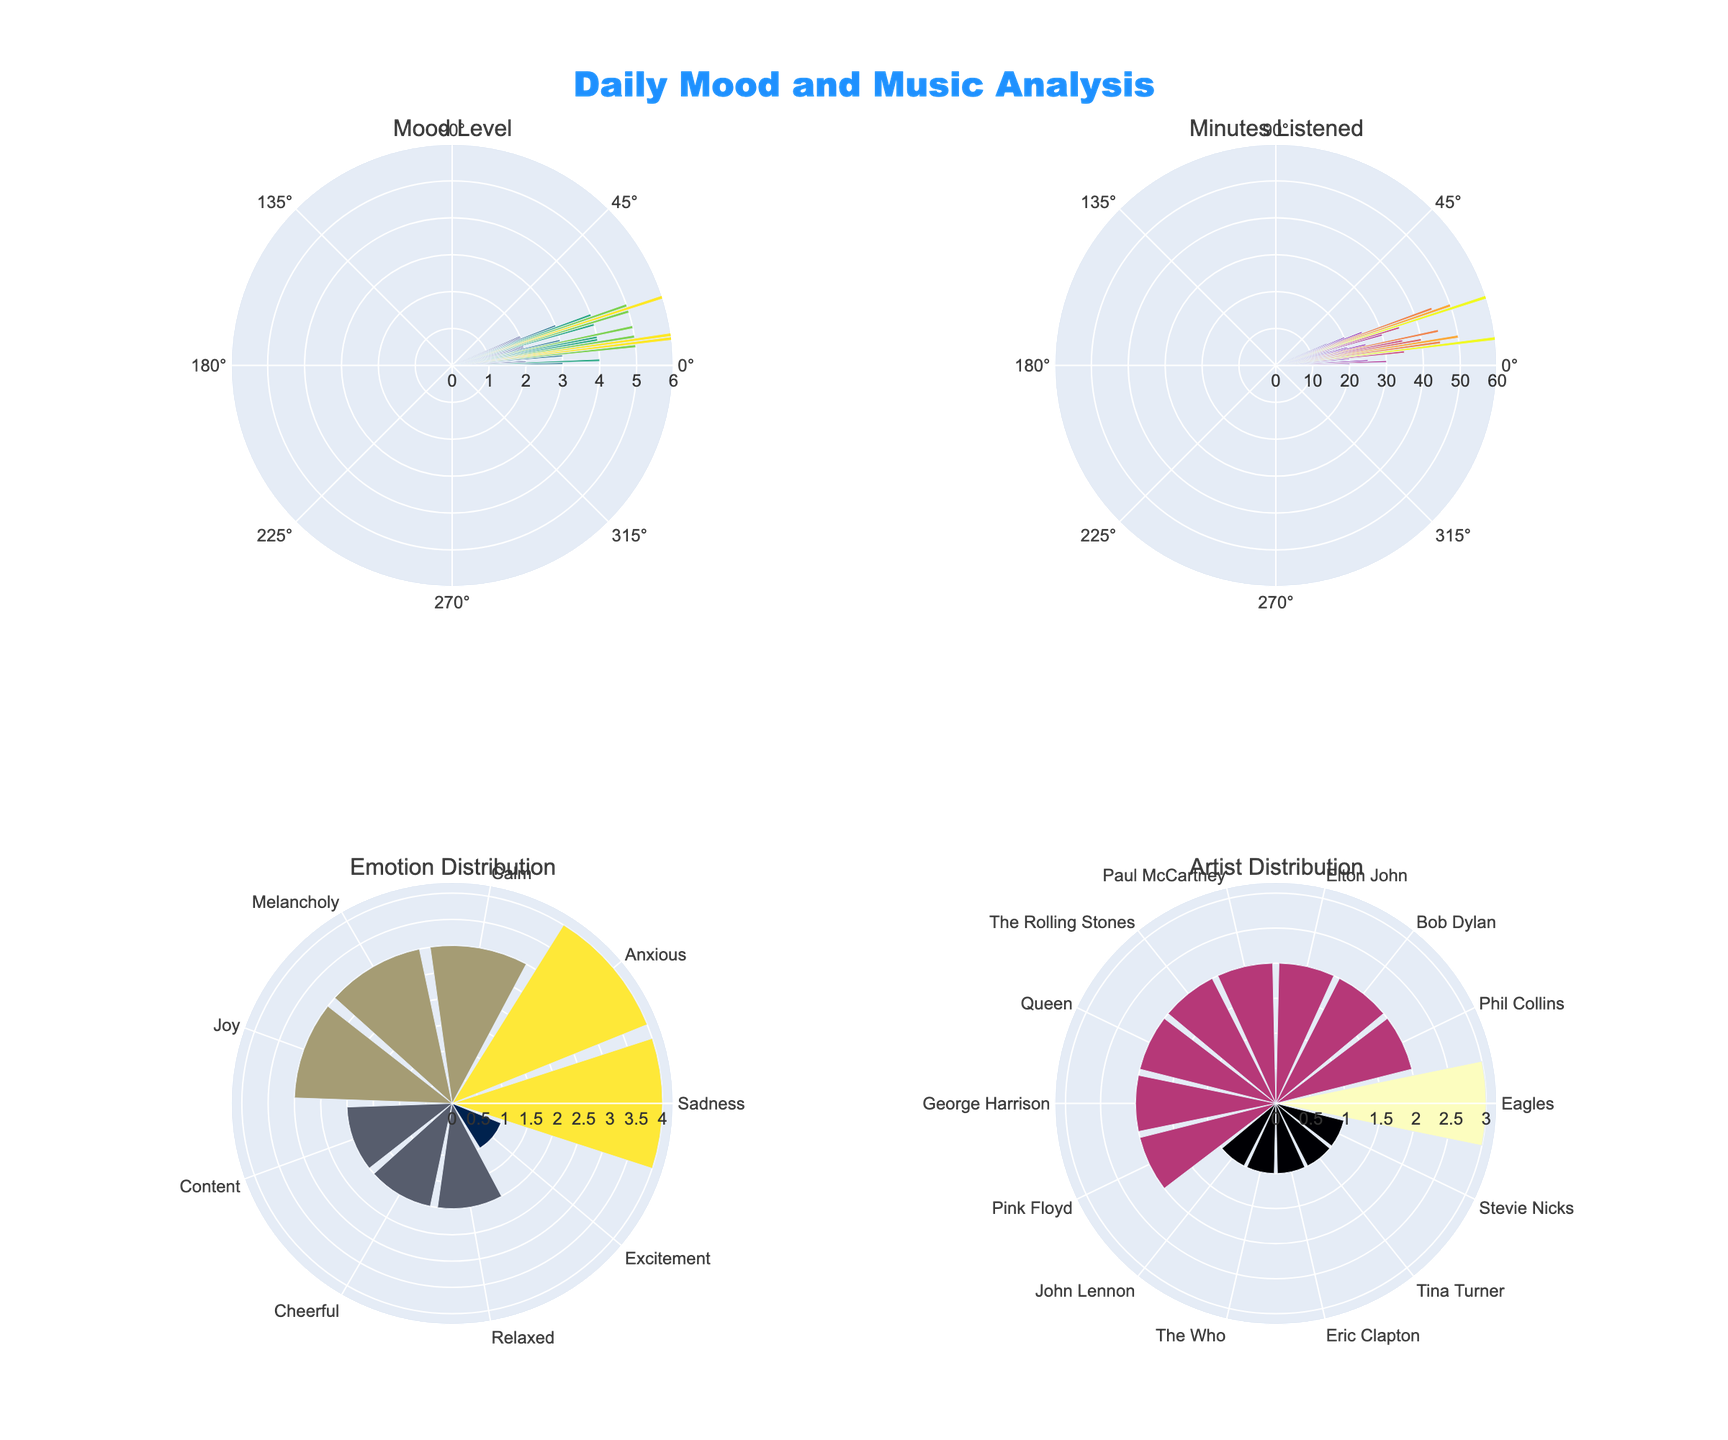which time of day has the highest mood level? By observing the 'Mood Level' subplot in the figure, the time corresponding to the highest radial value represents the highest mood level.
Answer: 07:00 which emotion is observed most frequently throughout the day? By looking at the 'Emotion Distribution' subplot, count the bars and identify the emotion with the highest bar.
Answer: Anxious between 'minutes listened' and 'mood level', which variable has a wider range of values throughout the day? Compare the radial axis range of 'Minutes Listened' and 'Mood Level' subplots; minutes listened ranges up to 60, while mood level ranges up to 6.
Answer: Minutes Listened what time of the day has the highest minutes listened? Look at the 'Minutes Listened' subplot and find the time with the highest radial value.
Answer: 07:00 which artist has the most frequent listening occurrences? Check the 'Artist Distribution' subplot, counting the height of the bars to identify the artist with the largest bar.
Answer: Eagles how many times is 'relaxed' emotions recorded throughout the day? Refer to the 'Emotion Distribution' subplot, looking at the 'Relaxed' bar and checking its value.
Answer: 2 are cheerful moods more frequent in the morning or evening? Look at the 'Mood Level' subplot, identify 'Cheerful' moods, and compare their frequencies between morning and evening hours.
Answer: Evening which emotion has the second-highest occurrence? In the 'Emotion Distribution' subplot, identify the second tallest bar.
Answer: Sadness 